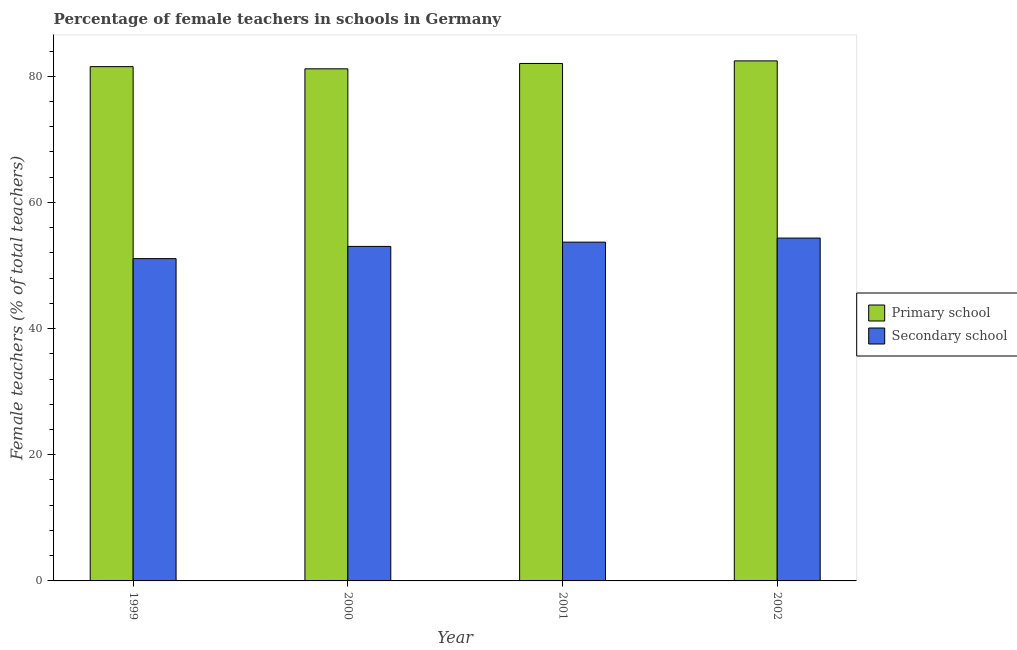How many different coloured bars are there?
Ensure brevity in your answer.  2. How many groups of bars are there?
Your answer should be compact. 4. Are the number of bars per tick equal to the number of legend labels?
Keep it short and to the point. Yes. How many bars are there on the 3rd tick from the right?
Keep it short and to the point. 2. What is the label of the 4th group of bars from the left?
Your response must be concise. 2002. In how many cases, is the number of bars for a given year not equal to the number of legend labels?
Ensure brevity in your answer.  0. What is the percentage of female teachers in primary schools in 1999?
Your answer should be compact. 81.53. Across all years, what is the maximum percentage of female teachers in primary schools?
Offer a very short reply. 82.44. Across all years, what is the minimum percentage of female teachers in primary schools?
Make the answer very short. 81.18. In which year was the percentage of female teachers in secondary schools maximum?
Offer a terse response. 2002. What is the total percentage of female teachers in primary schools in the graph?
Your answer should be compact. 327.18. What is the difference between the percentage of female teachers in secondary schools in 1999 and that in 2002?
Your response must be concise. -3.26. What is the difference between the percentage of female teachers in secondary schools in 2001 and the percentage of female teachers in primary schools in 2002?
Give a very brief answer. -0.65. What is the average percentage of female teachers in secondary schools per year?
Provide a succinct answer. 53.04. In how many years, is the percentage of female teachers in primary schools greater than 44 %?
Offer a terse response. 4. What is the ratio of the percentage of female teachers in secondary schools in 2000 to that in 2002?
Your answer should be very brief. 0.98. Is the percentage of female teachers in secondary schools in 2001 less than that in 2002?
Offer a very short reply. Yes. What is the difference between the highest and the second highest percentage of female teachers in secondary schools?
Give a very brief answer. 0.65. What is the difference between the highest and the lowest percentage of female teachers in primary schools?
Ensure brevity in your answer.  1.26. Is the sum of the percentage of female teachers in secondary schools in 1999 and 2002 greater than the maximum percentage of female teachers in primary schools across all years?
Your response must be concise. Yes. What does the 1st bar from the left in 2002 represents?
Keep it short and to the point. Primary school. What does the 1st bar from the right in 2002 represents?
Your answer should be compact. Secondary school. How many bars are there?
Ensure brevity in your answer.  8. How many years are there in the graph?
Make the answer very short. 4. What is the difference between two consecutive major ticks on the Y-axis?
Offer a terse response. 20. Are the values on the major ticks of Y-axis written in scientific E-notation?
Keep it short and to the point. No. Does the graph contain any zero values?
Keep it short and to the point. No. Where does the legend appear in the graph?
Your response must be concise. Center right. How many legend labels are there?
Your answer should be very brief. 2. What is the title of the graph?
Provide a short and direct response. Percentage of female teachers in schools in Germany. Does "IMF concessional" appear as one of the legend labels in the graph?
Make the answer very short. No. What is the label or title of the Y-axis?
Offer a terse response. Female teachers (% of total teachers). What is the Female teachers (% of total teachers) in Primary school in 1999?
Give a very brief answer. 81.53. What is the Female teachers (% of total teachers) of Secondary school in 1999?
Offer a terse response. 51.09. What is the Female teachers (% of total teachers) in Primary school in 2000?
Provide a succinct answer. 81.18. What is the Female teachers (% of total teachers) of Secondary school in 2000?
Your answer should be very brief. 53.03. What is the Female teachers (% of total teachers) in Primary school in 2001?
Your response must be concise. 82.03. What is the Female teachers (% of total teachers) in Secondary school in 2001?
Offer a terse response. 53.71. What is the Female teachers (% of total teachers) of Primary school in 2002?
Provide a succinct answer. 82.44. What is the Female teachers (% of total teachers) of Secondary school in 2002?
Make the answer very short. 54.35. Across all years, what is the maximum Female teachers (% of total teachers) in Primary school?
Offer a very short reply. 82.44. Across all years, what is the maximum Female teachers (% of total teachers) in Secondary school?
Offer a very short reply. 54.35. Across all years, what is the minimum Female teachers (% of total teachers) of Primary school?
Provide a short and direct response. 81.18. Across all years, what is the minimum Female teachers (% of total teachers) of Secondary school?
Provide a succinct answer. 51.09. What is the total Female teachers (% of total teachers) in Primary school in the graph?
Keep it short and to the point. 327.18. What is the total Female teachers (% of total teachers) in Secondary school in the graph?
Give a very brief answer. 212.18. What is the difference between the Female teachers (% of total teachers) in Primary school in 1999 and that in 2000?
Make the answer very short. 0.35. What is the difference between the Female teachers (% of total teachers) in Secondary school in 1999 and that in 2000?
Ensure brevity in your answer.  -1.93. What is the difference between the Female teachers (% of total teachers) in Primary school in 1999 and that in 2001?
Ensure brevity in your answer.  -0.5. What is the difference between the Female teachers (% of total teachers) in Secondary school in 1999 and that in 2001?
Your answer should be very brief. -2.61. What is the difference between the Female teachers (% of total teachers) in Primary school in 1999 and that in 2002?
Offer a very short reply. -0.91. What is the difference between the Female teachers (% of total teachers) in Secondary school in 1999 and that in 2002?
Ensure brevity in your answer.  -3.26. What is the difference between the Female teachers (% of total teachers) in Primary school in 2000 and that in 2001?
Keep it short and to the point. -0.85. What is the difference between the Female teachers (% of total teachers) of Secondary school in 2000 and that in 2001?
Your answer should be compact. -0.68. What is the difference between the Female teachers (% of total teachers) of Primary school in 2000 and that in 2002?
Provide a succinct answer. -1.26. What is the difference between the Female teachers (% of total teachers) of Secondary school in 2000 and that in 2002?
Keep it short and to the point. -1.32. What is the difference between the Female teachers (% of total teachers) in Primary school in 2001 and that in 2002?
Provide a short and direct response. -0.41. What is the difference between the Female teachers (% of total teachers) of Secondary school in 2001 and that in 2002?
Your answer should be very brief. -0.65. What is the difference between the Female teachers (% of total teachers) in Primary school in 1999 and the Female teachers (% of total teachers) in Secondary school in 2000?
Your response must be concise. 28.5. What is the difference between the Female teachers (% of total teachers) in Primary school in 1999 and the Female teachers (% of total teachers) in Secondary school in 2001?
Ensure brevity in your answer.  27.82. What is the difference between the Female teachers (% of total teachers) of Primary school in 1999 and the Female teachers (% of total teachers) of Secondary school in 2002?
Offer a terse response. 27.18. What is the difference between the Female teachers (% of total teachers) in Primary school in 2000 and the Female teachers (% of total teachers) in Secondary school in 2001?
Offer a very short reply. 27.48. What is the difference between the Female teachers (% of total teachers) in Primary school in 2000 and the Female teachers (% of total teachers) in Secondary school in 2002?
Your answer should be very brief. 26.83. What is the difference between the Female teachers (% of total teachers) of Primary school in 2001 and the Female teachers (% of total teachers) of Secondary school in 2002?
Your answer should be compact. 27.68. What is the average Female teachers (% of total teachers) of Primary school per year?
Provide a succinct answer. 81.8. What is the average Female teachers (% of total teachers) in Secondary school per year?
Provide a short and direct response. 53.04. In the year 1999, what is the difference between the Female teachers (% of total teachers) in Primary school and Female teachers (% of total teachers) in Secondary school?
Provide a short and direct response. 30.43. In the year 2000, what is the difference between the Female teachers (% of total teachers) in Primary school and Female teachers (% of total teachers) in Secondary school?
Ensure brevity in your answer.  28.15. In the year 2001, what is the difference between the Female teachers (% of total teachers) in Primary school and Female teachers (% of total teachers) in Secondary school?
Your answer should be compact. 28.33. In the year 2002, what is the difference between the Female teachers (% of total teachers) of Primary school and Female teachers (% of total teachers) of Secondary school?
Your response must be concise. 28.09. What is the ratio of the Female teachers (% of total teachers) of Secondary school in 1999 to that in 2000?
Provide a short and direct response. 0.96. What is the ratio of the Female teachers (% of total teachers) of Secondary school in 1999 to that in 2001?
Make the answer very short. 0.95. What is the ratio of the Female teachers (% of total teachers) in Primary school in 1999 to that in 2002?
Offer a terse response. 0.99. What is the ratio of the Female teachers (% of total teachers) in Secondary school in 1999 to that in 2002?
Offer a very short reply. 0.94. What is the ratio of the Female teachers (% of total teachers) of Primary school in 2000 to that in 2001?
Your response must be concise. 0.99. What is the ratio of the Female teachers (% of total teachers) in Secondary school in 2000 to that in 2001?
Provide a short and direct response. 0.99. What is the ratio of the Female teachers (% of total teachers) of Primary school in 2000 to that in 2002?
Provide a succinct answer. 0.98. What is the ratio of the Female teachers (% of total teachers) in Secondary school in 2000 to that in 2002?
Provide a short and direct response. 0.98. What is the ratio of the Female teachers (% of total teachers) in Primary school in 2001 to that in 2002?
Keep it short and to the point. 0.99. What is the ratio of the Female teachers (% of total teachers) of Secondary school in 2001 to that in 2002?
Your response must be concise. 0.99. What is the difference between the highest and the second highest Female teachers (% of total teachers) of Primary school?
Your answer should be compact. 0.41. What is the difference between the highest and the second highest Female teachers (% of total teachers) of Secondary school?
Give a very brief answer. 0.65. What is the difference between the highest and the lowest Female teachers (% of total teachers) in Primary school?
Your answer should be compact. 1.26. What is the difference between the highest and the lowest Female teachers (% of total teachers) of Secondary school?
Your answer should be compact. 3.26. 